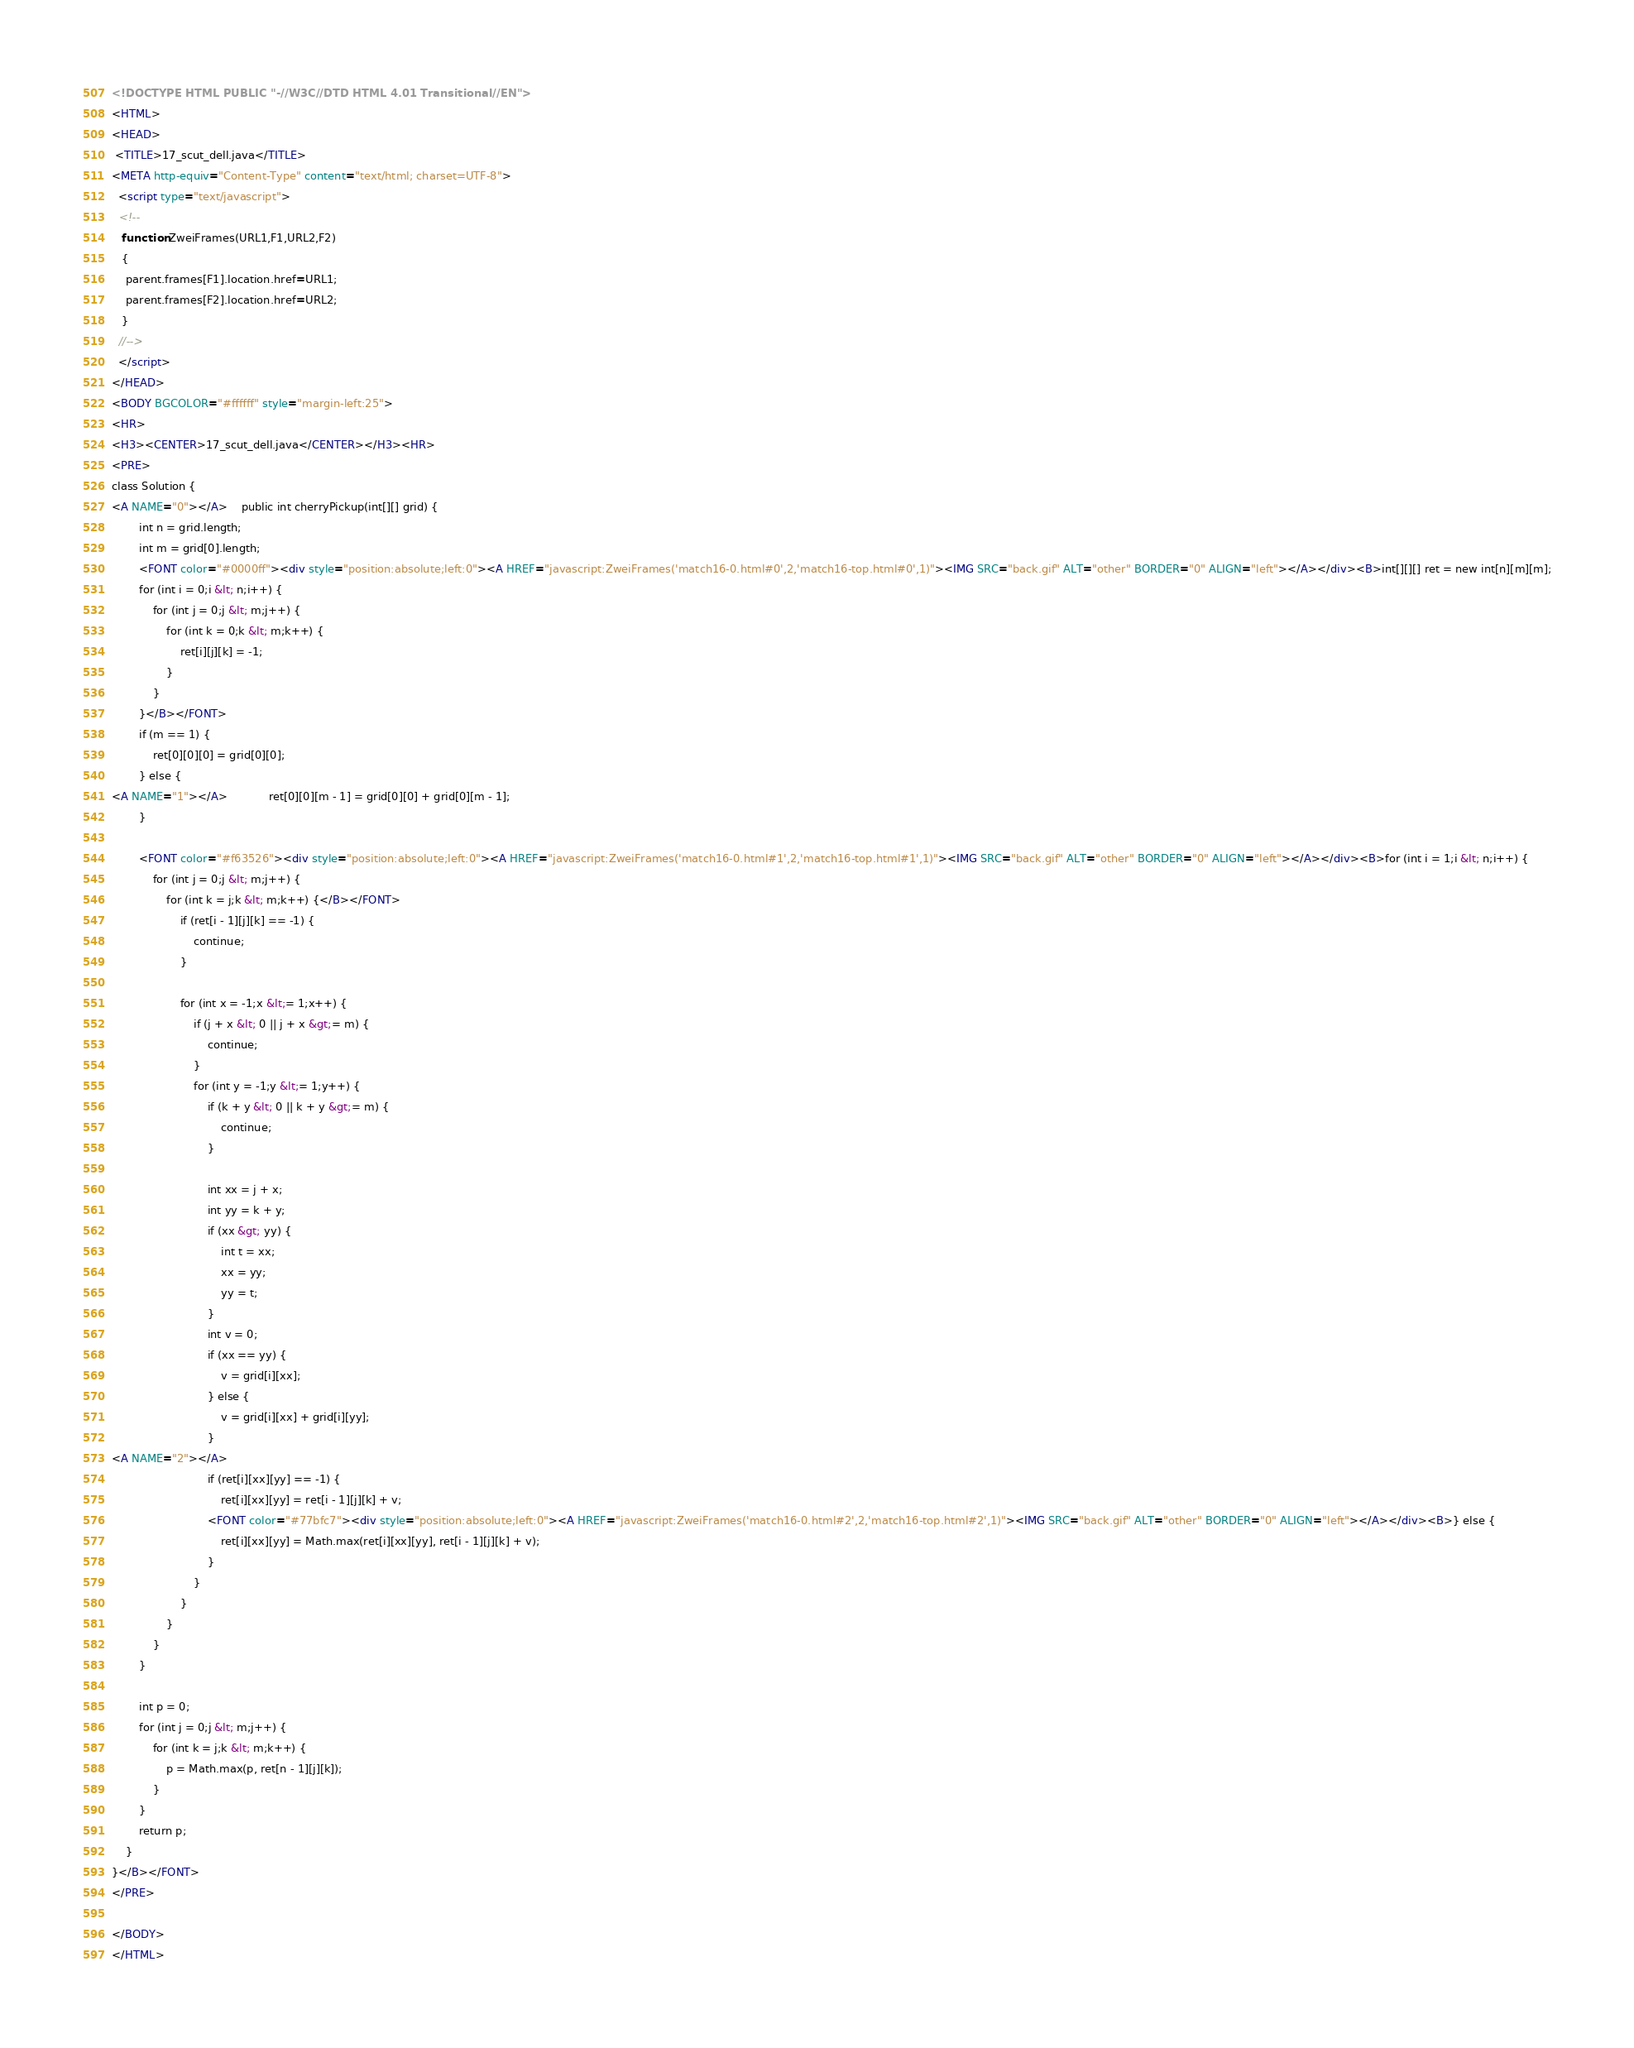<code> <loc_0><loc_0><loc_500><loc_500><_HTML_><!DOCTYPE HTML PUBLIC "-//W3C//DTD HTML 4.01 Transitional//EN">
<HTML>
<HEAD>
 <TITLE>17_scut_dell.java</TITLE>
<META http-equiv="Content-Type" content="text/html; charset=UTF-8">
  <script type="text/javascript">
  <!--
   function ZweiFrames(URL1,F1,URL2,F2)
   {
    parent.frames[F1].location.href=URL1;
    parent.frames[F2].location.href=URL2;
   }
  //-->
  </script>
</HEAD>
<BODY BGCOLOR="#ffffff" style="margin-left:25">
<HR>
<H3><CENTER>17_scut_dell.java</CENTER></H3><HR>
<PRE>
class Solution {
<A NAME="0"></A>    public int cherryPickup(int[][] grid) {
        int n = grid.length;
        int m = grid[0].length;
        <FONT color="#0000ff"><div style="position:absolute;left:0"><A HREF="javascript:ZweiFrames('match16-0.html#0',2,'match16-top.html#0',1)"><IMG SRC="back.gif" ALT="other" BORDER="0" ALIGN="left"></A></div><B>int[][][] ret = new int[n][m][m];
        for (int i = 0;i &lt; n;i++) {
            for (int j = 0;j &lt; m;j++) {
                for (int k = 0;k &lt; m;k++) {
                    ret[i][j][k] = -1;
                }
            }
        }</B></FONT>
        if (m == 1) {
            ret[0][0][0] = grid[0][0];
        } else {
<A NAME="1"></A>            ret[0][0][m - 1] = grid[0][0] + grid[0][m - 1];
        }
        
        <FONT color="#f63526"><div style="position:absolute;left:0"><A HREF="javascript:ZweiFrames('match16-0.html#1',2,'match16-top.html#1',1)"><IMG SRC="back.gif" ALT="other" BORDER="0" ALIGN="left"></A></div><B>for (int i = 1;i &lt; n;i++) {
            for (int j = 0;j &lt; m;j++) {
                for (int k = j;k &lt; m;k++) {</B></FONT>
                    if (ret[i - 1][j][k] == -1) {
                        continue;
                    }
                    
                    for (int x = -1;x &lt;= 1;x++) {
                        if (j + x &lt; 0 || j + x &gt;= m) {
                            continue;
                        }
                        for (int y = -1;y &lt;= 1;y++) {
                            if (k + y &lt; 0 || k + y &gt;= m) {
                                continue;
                            }
                            
                            int xx = j + x;
                            int yy = k + y;
                            if (xx &gt; yy) {
                                int t = xx;
                                xx = yy;
                                yy = t;
                            }
                            int v = 0;
                            if (xx == yy) {
                                v = grid[i][xx];
                            } else {
                                v = grid[i][xx] + grid[i][yy];
                            }
<A NAME="2"></A>                            
                            if (ret[i][xx][yy] == -1) {
                                ret[i][xx][yy] = ret[i - 1][j][k] + v;
                            <FONT color="#77bfc7"><div style="position:absolute;left:0"><A HREF="javascript:ZweiFrames('match16-0.html#2',2,'match16-top.html#2',1)"><IMG SRC="back.gif" ALT="other" BORDER="0" ALIGN="left"></A></div><B>} else {
                                ret[i][xx][yy] = Math.max(ret[i][xx][yy], ret[i - 1][j][k] + v);
                            }
                        }
                    }
                }
            }
        }
        
        int p = 0;
        for (int j = 0;j &lt; m;j++) {
            for (int k = j;k &lt; m;k++) {
                p = Math.max(p, ret[n - 1][j][k]);
            }
        }
        return p;
    }
}</B></FONT>
</PRE>

</BODY>
</HTML>
</code> 